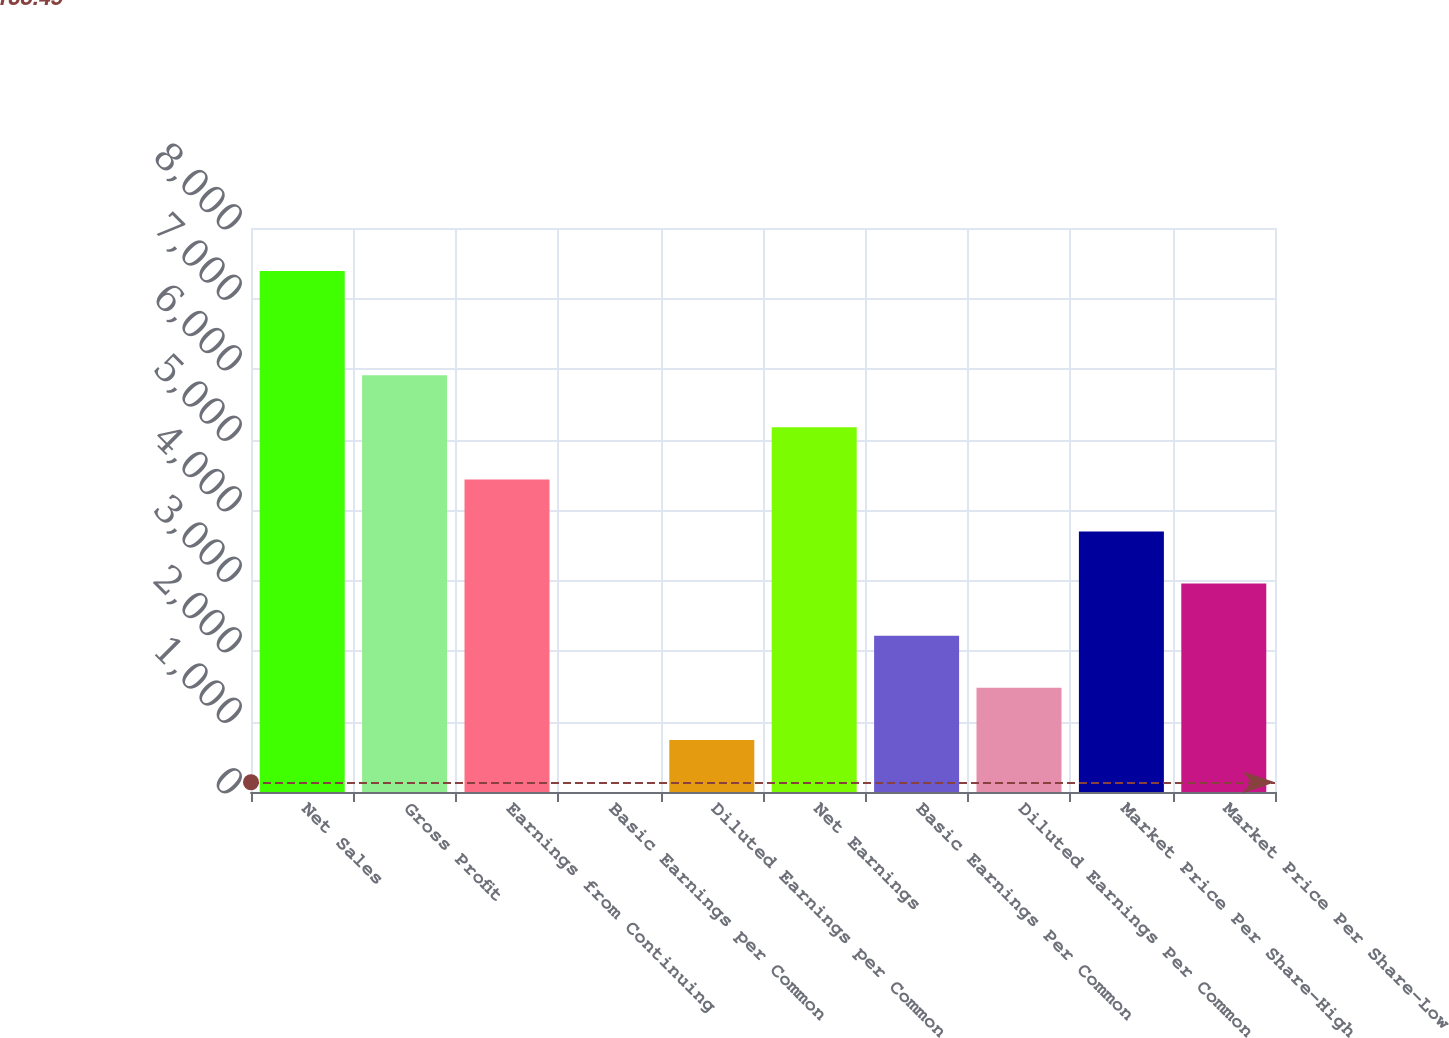Convert chart. <chart><loc_0><loc_0><loc_500><loc_500><bar_chart><fcel>Net Sales<fcel>Gross Profit<fcel>Earnings from Continuing<fcel>Basic Earnings per Common<fcel>Diluted Earnings per Common<fcel>Net Earnings<fcel>Basic Earnings Per Common<fcel>Diluted Earnings Per Common<fcel>Market Price Per Share-High<fcel>Market Price Per Share-Low<nl><fcel>7390<fcel>5912.07<fcel>4434.11<fcel>0.23<fcel>739.21<fcel>5173.09<fcel>2217.17<fcel>1478.19<fcel>3695.13<fcel>2956.15<nl></chart> 